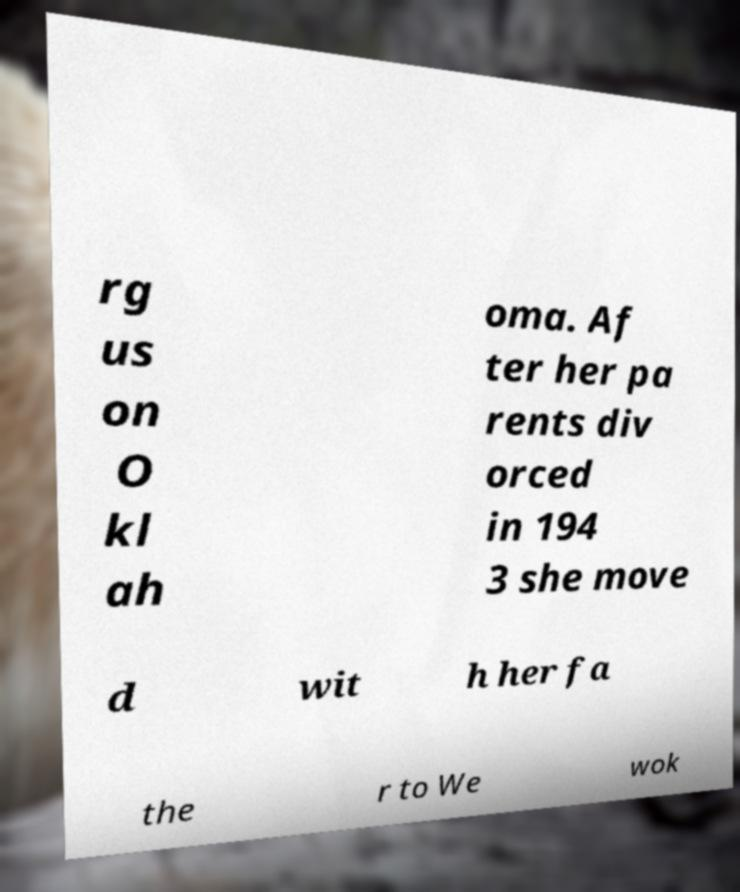Could you assist in decoding the text presented in this image and type it out clearly? rg us on O kl ah oma. Af ter her pa rents div orced in 194 3 she move d wit h her fa the r to We wok 